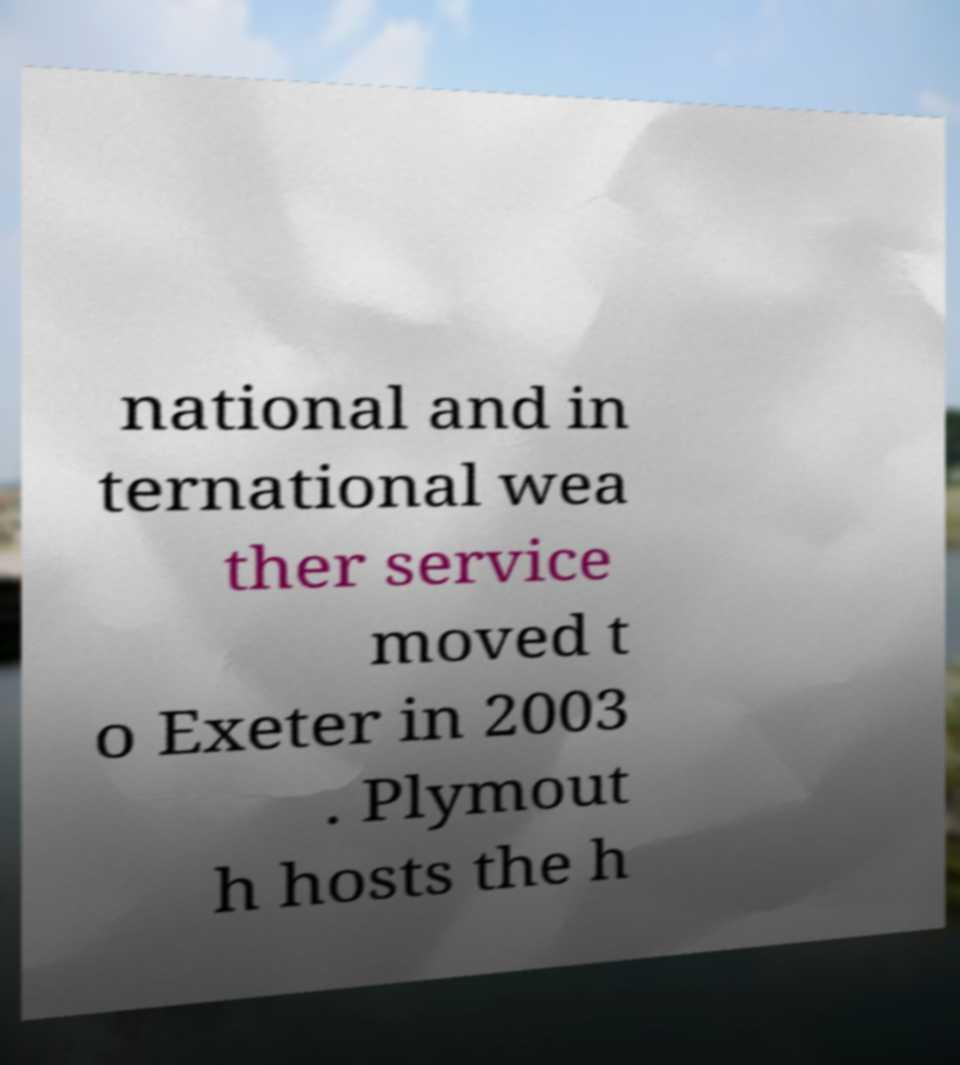For documentation purposes, I need the text within this image transcribed. Could you provide that? national and in ternational wea ther service moved t o Exeter in 2003 . Plymout h hosts the h 